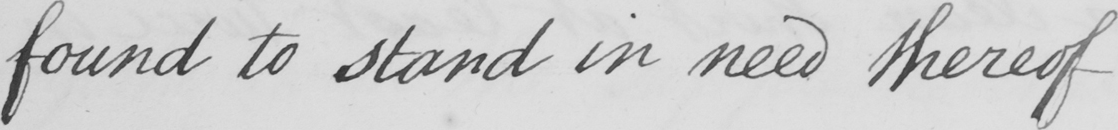What does this handwritten line say? found to stand in need thereof 